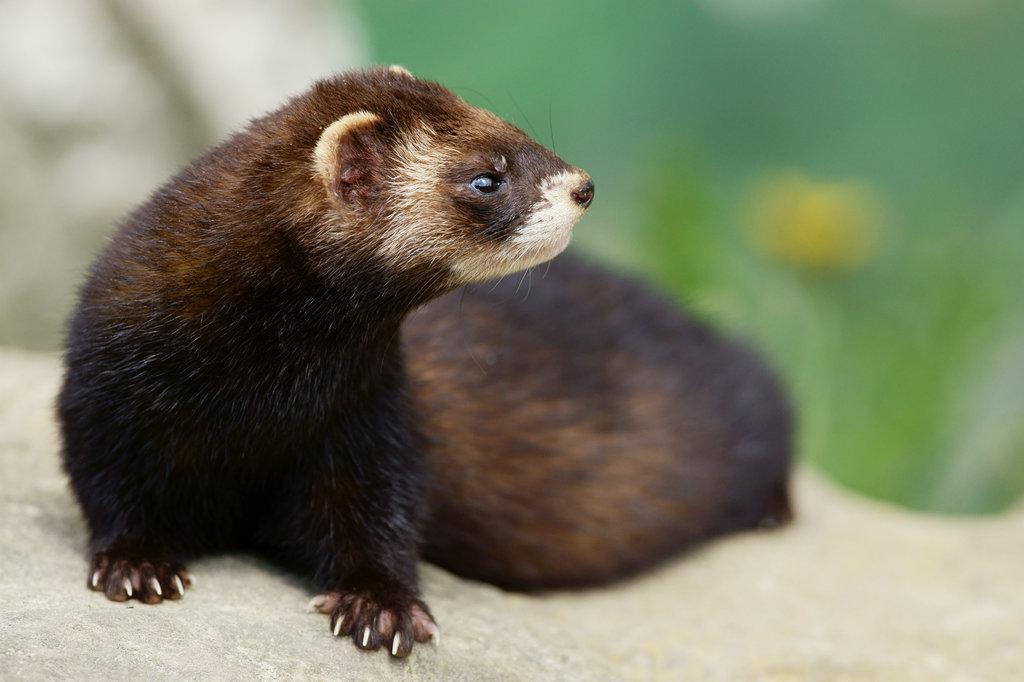Describe this image in one or two sentences. In this picture we can see a ferret on the surface. Behind the ferret, there is a blurred background. 